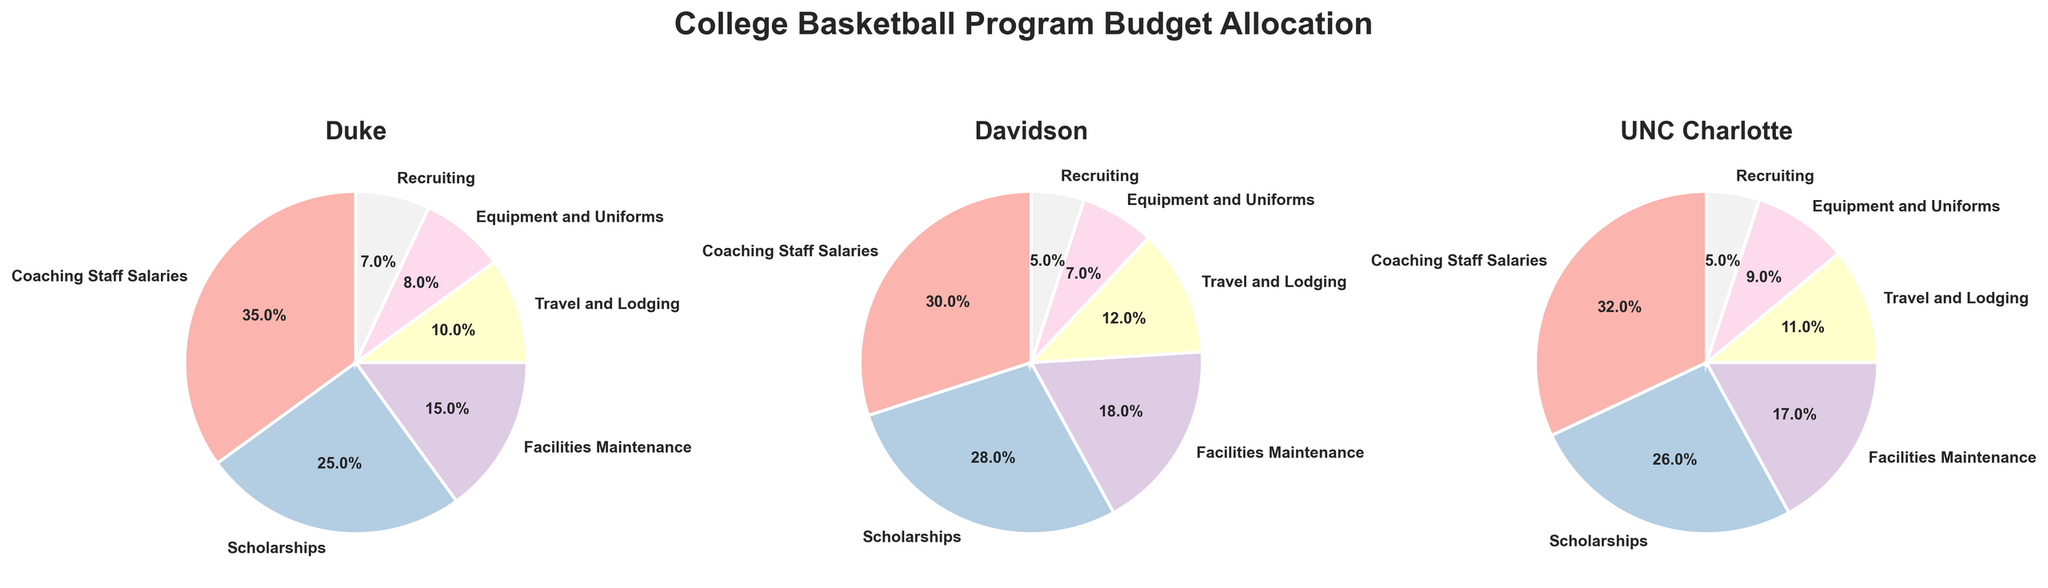What is the title of the figure? The title is displayed at the top of the figure and is "College Basketball Program Budget Allocation".
Answer: College Basketball Program Budget Allocation Which program allocates the highest percentage of its budget to Coaching Staff Salaries? By comparing the pie charts, Duke allocates the highest percentage to Coaching Staff Salaries at 35%.
Answer: Duke How much more of its budget does Davidson allocate to Scholarships compared to Recruiting? Davidson allocates 28% to Scholarships and 5% to Recruiting. The difference is calculated as 28% - 5% = 23%.
Answer: 23% Which category has the smallest allocation in UNC Charlotte's budget? The smallest allocation can be seen from the pie chart for UNC Charlotte, which is Recruiting at 5%.
Answer: Recruiting Between Duke and Davidson, which program spends more on Facilities Maintenance? Duke allocates 15% to Facilities Maintenance while Davidson allocates 18%. Davidson allocates more.
Answer: Davidson How do the travel and lodging expenses of Duke and UNC Charlotte compare? Duke allocates 10% to Travel and Lodging and UNC Charlotte allocates 11%. UNC Charlotte spends 1% more.
Answer: UNC Charlotte What is the combined percentage of Travel and Lodging and Equipment and Uniforms for Davidson? Davidson allocates 12% to Travel and Lodging and 7% to Equipment and Uniforms. The combined percentage is calculated as 12% + 7% = 19%.
Answer: 19% Which two programs have the same allocation for Recruiting? By comparing the pie charts, we see that both Davidson and UNC Charlotte allocate 5% to Recruiting.
Answer: Davidson and UNC Charlotte Which expense category has the highest variety in allocation percentages across all programs? Analyzing all pie charts, we see that Coaching Staff Salaries have the most variation: Duke at 35%, Davidson at 30%, and UNC Charlotte at 32%.
Answer: Coaching Staff Salaries Do any programs allocate exactly 8% to the same category? By looking at the pie charts, Duke allocates 8% to Equipment and Uniforms, and this percentage is not repeated in the same category by any other program.
Answer: No 